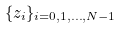Convert formula to latex. <formula><loc_0><loc_0><loc_500><loc_500>\{ z _ { i } \} _ { i = 0 , 1 , \dots , N - 1 }</formula> 